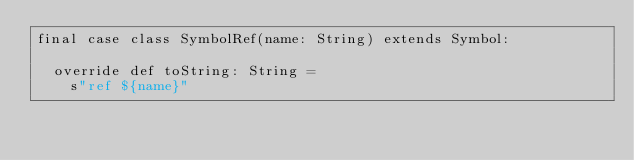<code> <loc_0><loc_0><loc_500><loc_500><_Scala_>final case class SymbolRef(name: String) extends Symbol:

  override def toString: String =
    s"ref ${name}"
</code> 